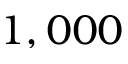Convert formula to latex. <formula><loc_0><loc_0><loc_500><loc_500>1 , 0 0 0</formula> 